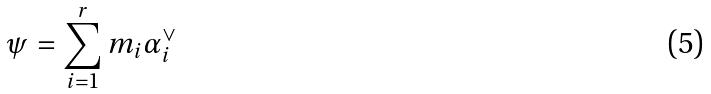<formula> <loc_0><loc_0><loc_500><loc_500>\psi = \sum _ { i = 1 } ^ { r } m _ { i } \alpha _ { i } ^ { \vee }</formula> 